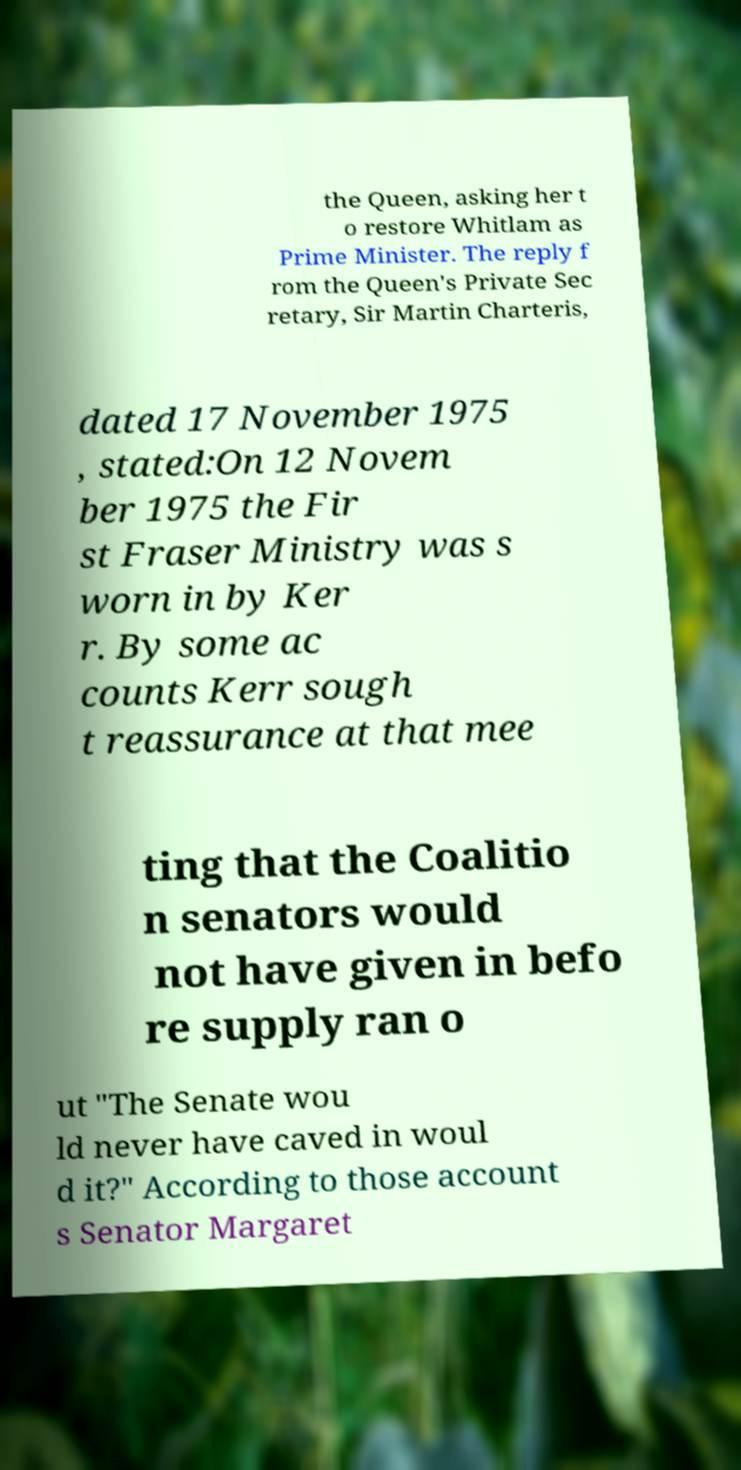Can you read and provide the text displayed in the image?This photo seems to have some interesting text. Can you extract and type it out for me? the Queen, asking her t o restore Whitlam as Prime Minister. The reply f rom the Queen's Private Sec retary, Sir Martin Charteris, dated 17 November 1975 , stated:On 12 Novem ber 1975 the Fir st Fraser Ministry was s worn in by Ker r. By some ac counts Kerr sough t reassurance at that mee ting that the Coalitio n senators would not have given in befo re supply ran o ut "The Senate wou ld never have caved in woul d it?" According to those account s Senator Margaret 